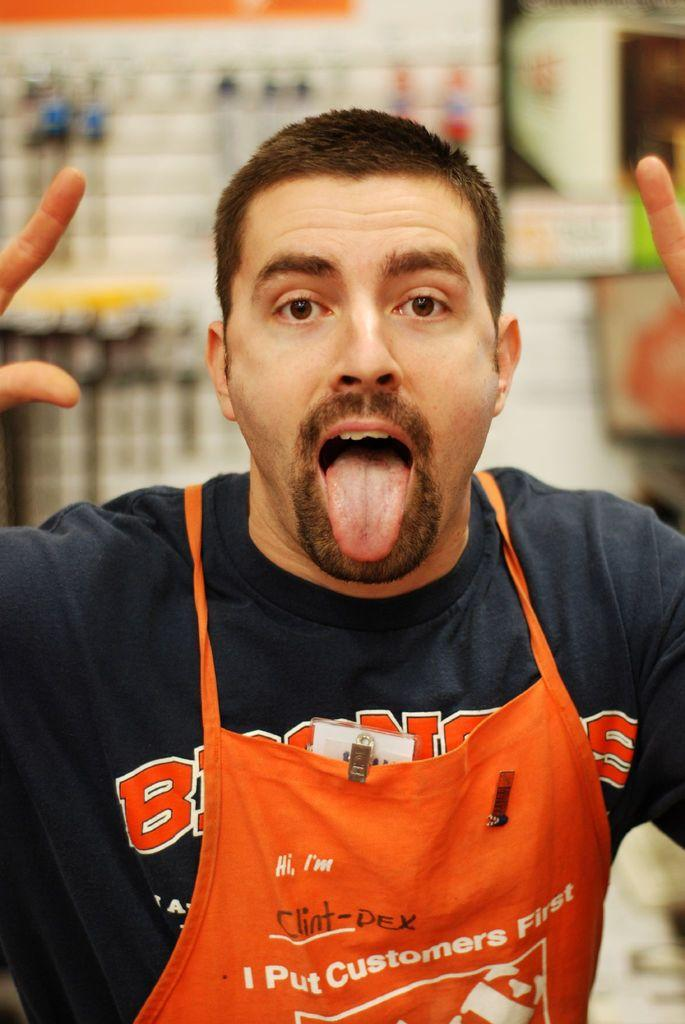Who is present in the image? There is a man in the image. Can you describe the background of the image? The background of the image is blurry. How many ants can be seen crawling on the man's hair in the image? There are no ants or hair visible in the image, so it is not possible to answer that question. 